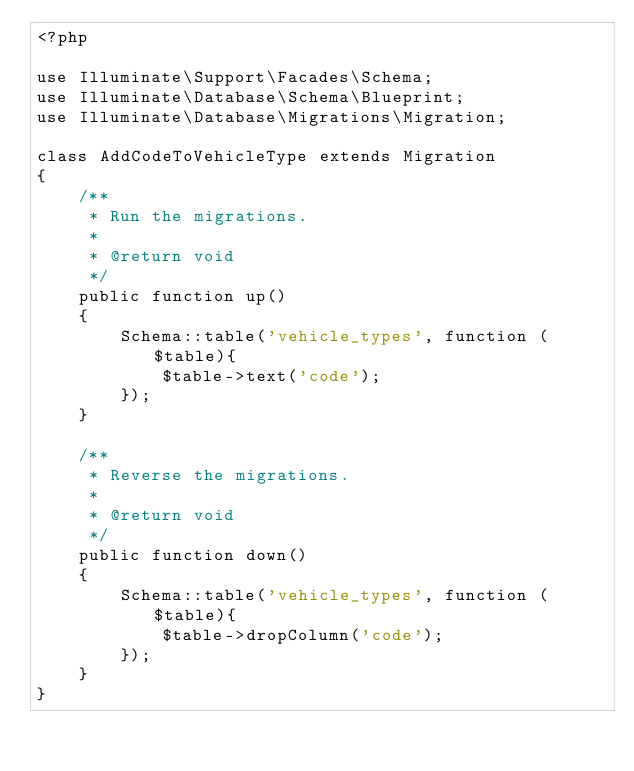<code> <loc_0><loc_0><loc_500><loc_500><_PHP_><?php

use Illuminate\Support\Facades\Schema;
use Illuminate\Database\Schema\Blueprint;
use Illuminate\Database\Migrations\Migration;

class AddCodeToVehicleType extends Migration
{
    /**
     * Run the migrations.
     *
     * @return void
     */
    public function up()
    {
        Schema::table('vehicle_types', function ($table){
            $table->text('code');
        });
    }

    /**
     * Reverse the migrations.
     *
     * @return void
     */
    public function down()
    {
        Schema::table('vehicle_types', function ($table){
            $table->dropColumn('code');
        });
    }
}
</code> 